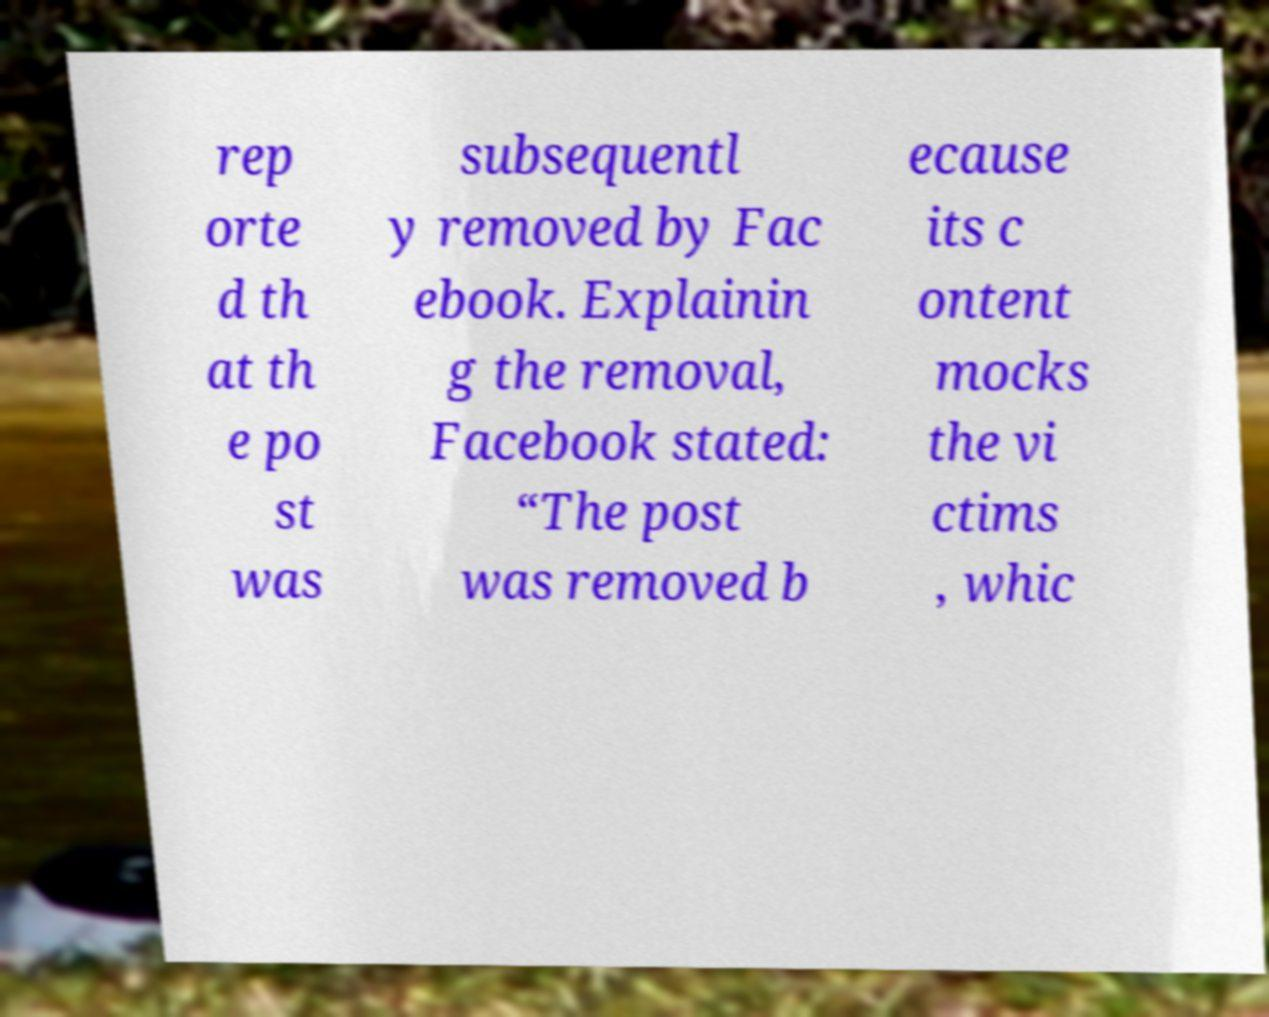Could you extract and type out the text from this image? rep orte d th at th e po st was subsequentl y removed by Fac ebook. Explainin g the removal, Facebook stated: “The post was removed b ecause its c ontent mocks the vi ctims , whic 